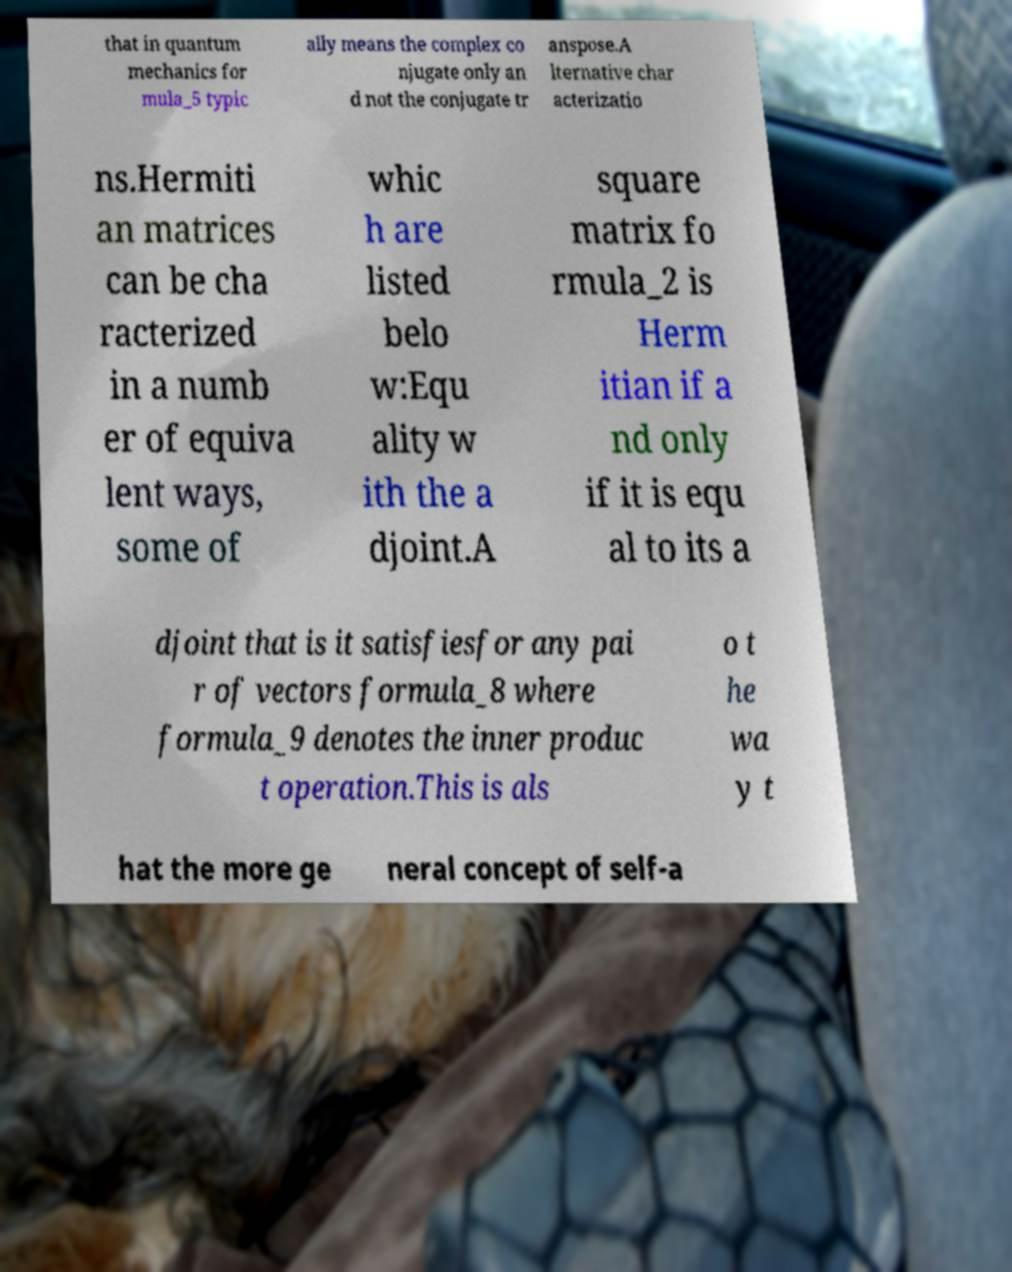What messages or text are displayed in this image? I need them in a readable, typed format. that in quantum mechanics for mula_5 typic ally means the complex co njugate only an d not the conjugate tr anspose.A lternative char acterizatio ns.Hermiti an matrices can be cha racterized in a numb er of equiva lent ways, some of whic h are listed belo w:Equ ality w ith the a djoint.A square matrix fo rmula_2 is Herm itian if a nd only if it is equ al to its a djoint that is it satisfiesfor any pai r of vectors formula_8 where formula_9 denotes the inner produc t operation.This is als o t he wa y t hat the more ge neral concept of self-a 